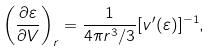<formula> <loc_0><loc_0><loc_500><loc_500>\left ( \frac { \partial \varepsilon } { \partial V } \right ) _ { r } = \frac { 1 } { 4 \pi r ^ { 3 } / 3 } [ v ^ { \prime } ( \varepsilon ) ] ^ { - 1 } ,</formula> 